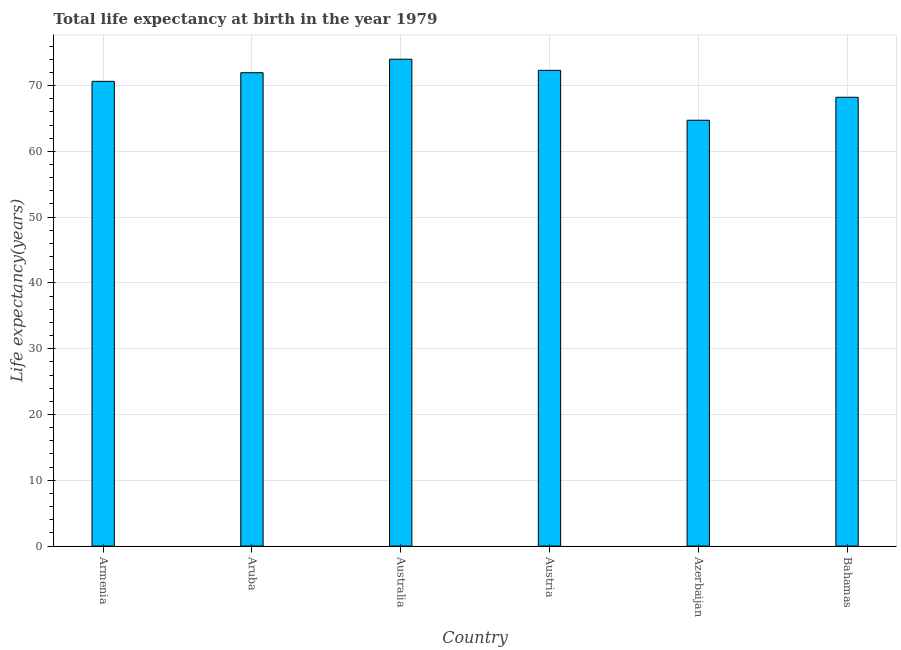Does the graph contain grids?
Ensure brevity in your answer.  Yes. What is the title of the graph?
Your answer should be compact. Total life expectancy at birth in the year 1979. What is the label or title of the Y-axis?
Provide a short and direct response. Life expectancy(years). What is the life expectancy at birth in Australia?
Your response must be concise. 74. Across all countries, what is the maximum life expectancy at birth?
Give a very brief answer. 74. Across all countries, what is the minimum life expectancy at birth?
Provide a succinct answer. 64.73. In which country was the life expectancy at birth minimum?
Your answer should be compact. Azerbaijan. What is the sum of the life expectancy at birth?
Your response must be concise. 421.86. What is the difference between the life expectancy at birth in Austria and Azerbaijan?
Your answer should be compact. 7.58. What is the average life expectancy at birth per country?
Make the answer very short. 70.31. What is the median life expectancy at birth?
Give a very brief answer. 71.3. In how many countries, is the life expectancy at birth greater than 72 years?
Ensure brevity in your answer.  2. What is the ratio of the life expectancy at birth in Australia to that in Austria?
Offer a very short reply. 1.02. Is the life expectancy at birth in Armenia less than that in Aruba?
Make the answer very short. Yes. What is the difference between the highest and the second highest life expectancy at birth?
Give a very brief answer. 1.69. What is the difference between the highest and the lowest life expectancy at birth?
Offer a terse response. 9.28. In how many countries, is the life expectancy at birth greater than the average life expectancy at birth taken over all countries?
Provide a succinct answer. 4. How many bars are there?
Make the answer very short. 6. How many countries are there in the graph?
Offer a terse response. 6. What is the Life expectancy(years) in Armenia?
Keep it short and to the point. 70.64. What is the Life expectancy(years) in Aruba?
Make the answer very short. 71.95. What is the Life expectancy(years) in Australia?
Your answer should be compact. 74. What is the Life expectancy(years) in Austria?
Provide a succinct answer. 72.31. What is the Life expectancy(years) of Azerbaijan?
Ensure brevity in your answer.  64.73. What is the Life expectancy(years) in Bahamas?
Offer a terse response. 68.22. What is the difference between the Life expectancy(years) in Armenia and Aruba?
Provide a succinct answer. -1.31. What is the difference between the Life expectancy(years) in Armenia and Australia?
Your answer should be compact. -3.36. What is the difference between the Life expectancy(years) in Armenia and Austria?
Keep it short and to the point. -1.67. What is the difference between the Life expectancy(years) in Armenia and Azerbaijan?
Make the answer very short. 5.91. What is the difference between the Life expectancy(years) in Armenia and Bahamas?
Give a very brief answer. 2.42. What is the difference between the Life expectancy(years) in Aruba and Australia?
Your answer should be very brief. -2.05. What is the difference between the Life expectancy(years) in Aruba and Austria?
Offer a terse response. -0.36. What is the difference between the Life expectancy(years) in Aruba and Azerbaijan?
Keep it short and to the point. 7.22. What is the difference between the Life expectancy(years) in Aruba and Bahamas?
Ensure brevity in your answer.  3.73. What is the difference between the Life expectancy(years) in Australia and Austria?
Make the answer very short. 1.69. What is the difference between the Life expectancy(years) in Australia and Azerbaijan?
Keep it short and to the point. 9.28. What is the difference between the Life expectancy(years) in Australia and Bahamas?
Your answer should be compact. 5.79. What is the difference between the Life expectancy(years) in Austria and Azerbaijan?
Your response must be concise. 7.58. What is the difference between the Life expectancy(years) in Austria and Bahamas?
Make the answer very short. 4.09. What is the difference between the Life expectancy(years) in Azerbaijan and Bahamas?
Your answer should be very brief. -3.49. What is the ratio of the Life expectancy(years) in Armenia to that in Australia?
Provide a succinct answer. 0.95. What is the ratio of the Life expectancy(years) in Armenia to that in Azerbaijan?
Ensure brevity in your answer.  1.09. What is the ratio of the Life expectancy(years) in Armenia to that in Bahamas?
Offer a very short reply. 1.04. What is the ratio of the Life expectancy(years) in Aruba to that in Australia?
Make the answer very short. 0.97. What is the ratio of the Life expectancy(years) in Aruba to that in Azerbaijan?
Provide a short and direct response. 1.11. What is the ratio of the Life expectancy(years) in Aruba to that in Bahamas?
Offer a very short reply. 1.05. What is the ratio of the Life expectancy(years) in Australia to that in Azerbaijan?
Provide a short and direct response. 1.14. What is the ratio of the Life expectancy(years) in Australia to that in Bahamas?
Your answer should be very brief. 1.08. What is the ratio of the Life expectancy(years) in Austria to that in Azerbaijan?
Provide a succinct answer. 1.12. What is the ratio of the Life expectancy(years) in Austria to that in Bahamas?
Offer a terse response. 1.06. What is the ratio of the Life expectancy(years) in Azerbaijan to that in Bahamas?
Give a very brief answer. 0.95. 